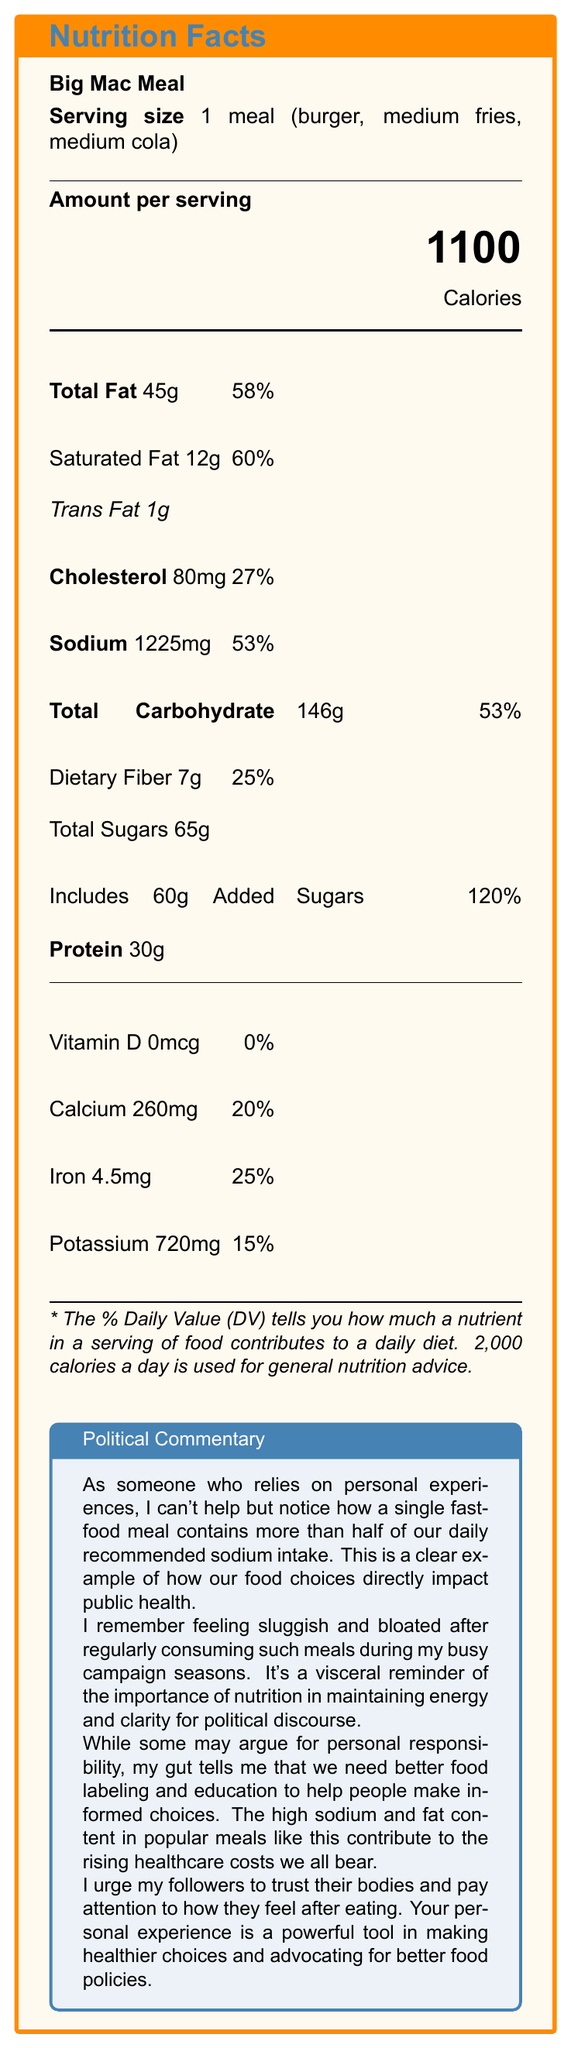what is the serving size of the Big Mac Meal? The document states the serving size is 1 meal consisting of a burger, medium fries, and medium cola.
Answer: 1 meal (burger, medium fries, medium cola) how many calories are in one Big Mac Meal? The document clearly states that one serving of the Big Mac Meal contains 1100 calories.
Answer: 1100 calories how much sodium does a Big Mac Meal contain? According to the document, the sodium content of one Big Mac Meal is 1225mg.
Answer: 1225mg what is the percent Daily Value for saturated fat in the Big Mac Meal? The document indicates that the saturated fat content is 12g, which is 60% of the Daily Value.
Answer: 60% what is the amount of added sugars in the Big Mac Meal? The document lists 60g of added sugars as part of the total sugar content.
Answer: 60g what percent of the Daily Value for calcium does the Big Mac Meal provide? A. 10% B. 15% C. 20% D. 25% Based on the document, the calcium content is 260mg, which is 20% of the Daily Value.
Answer: C. 20% how many grams of dietary fiber are in the Big Mac Meal? A. 5g B. 7g C. 9g D. 12g The document specifies that the meal contains 7g of dietary fiber, which is 25% of the Daily Value.
Answer: B. 7g is there any vitamin D in the Big Mac Meal? The document shows that the amount of vitamin D is 0mcg, which is 0% of the Daily Value.
Answer: No is the sodium content in the Big Mac Meal more than half of the daily recommended intake? The document indicates that the sodium content is 1225mg, which is 53% of the Daily Value, exceeding half of the daily recommended intake.
Answer: Yes summarize the main idea of the political commentary in the document. This summary includes the key points mentioned in the political commentary, focusing on personal experiences, public health, and policy implications.
Answer: The commentary highlights the high sodium and fat content in the Big Mac Meal and its implications for public health. It discusses the author's personal experiences of feeling sluggish and advocates for better food labeling and education to help people make informed choices. what are the total sugars in the Big Mac Meal? The document lists the total sugars as 65g.
Answer: 65g what is the total fat content in the Big Mac Meal? The document specifies that the total fat content in one serving of the Big Mac Meal is 45g, which is 58% of the Daily Value.
Answer: 45g how much protein does the Big Mac Meal have? The document notes that the Big Mac Meal contains 30g of protein.
Answer: 30g does the Big Mac Meal provide any potassium? The document mentions that the Big Mac Meal provides 720mg of potassium, which is 15% of the Daily Value.
Answer: Yes how often should I eat Big Mac Meals based on the nutritional information? The document provides nutritional information but does not offer guidance on how often one should consume such meals.
Answer: Not enough information 